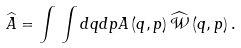<formula> <loc_0><loc_0><loc_500><loc_500>\widehat { A } = \int \, \int d q d p A \left ( q , p \right ) \widehat { \mathcal { W } } \left ( q , p \right ) .</formula> 